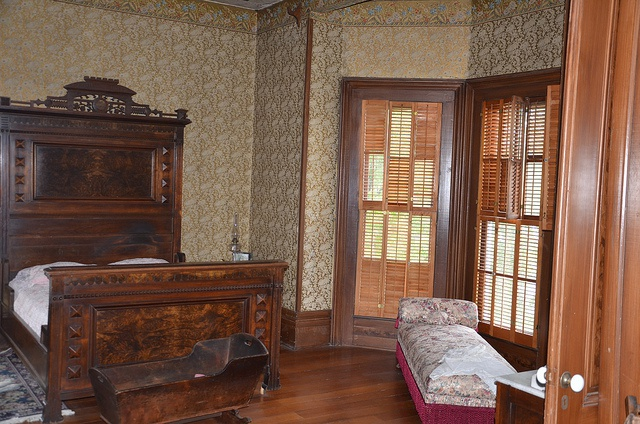Describe the objects in this image and their specific colors. I can see bed in olive, maroon, black, gray, and darkgray tones and bed in olive, darkgray, lightgray, maroon, and gray tones in this image. 